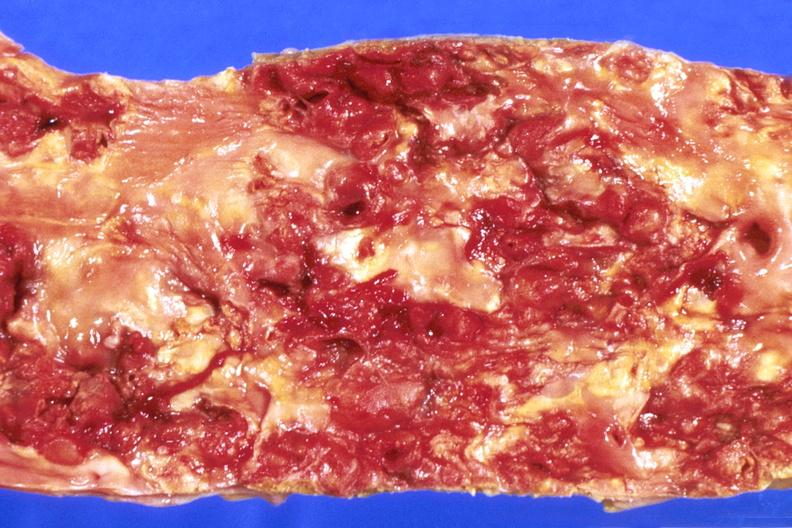where is this?
Answer the question using a single word or phrase. Heart 